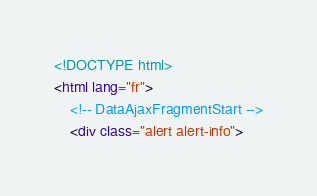Convert code to text. <code><loc_0><loc_0><loc_500><loc_500><_HTML_><!DOCTYPE html>
<html lang="fr">
	<!-- DataAjaxFragmentStart -->
	<div class="alert alert-info"></code> 